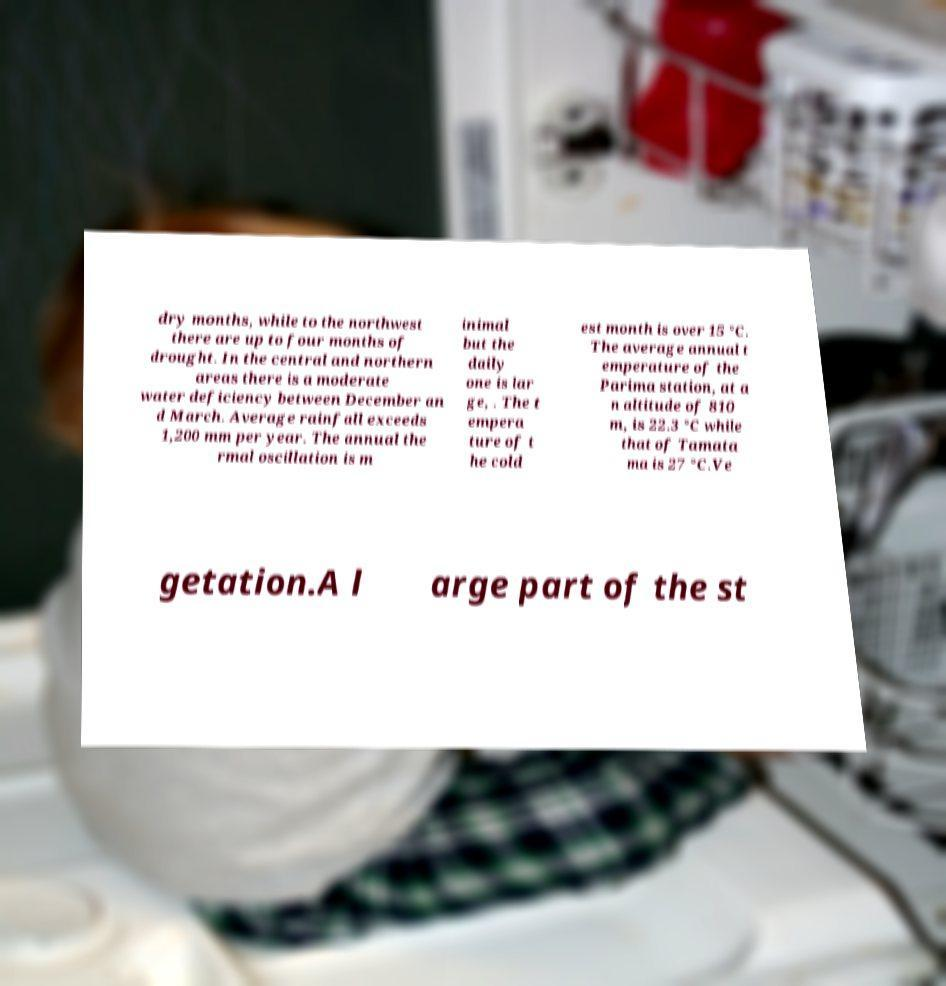What messages or text are displayed in this image? I need them in a readable, typed format. dry months, while to the northwest there are up to four months of drought. In the central and northern areas there is a moderate water deficiency between December an d March. Average rainfall exceeds 1,200 mm per year. The annual the rmal oscillation is m inimal but the daily one is lar ge, . The t empera ture of t he cold est month is over 15 °C. The average annual t emperature of the Parima station, at a n altitude of 810 m, is 22.3 °C while that of Tamata ma is 27 °C.Ve getation.A l arge part of the st 